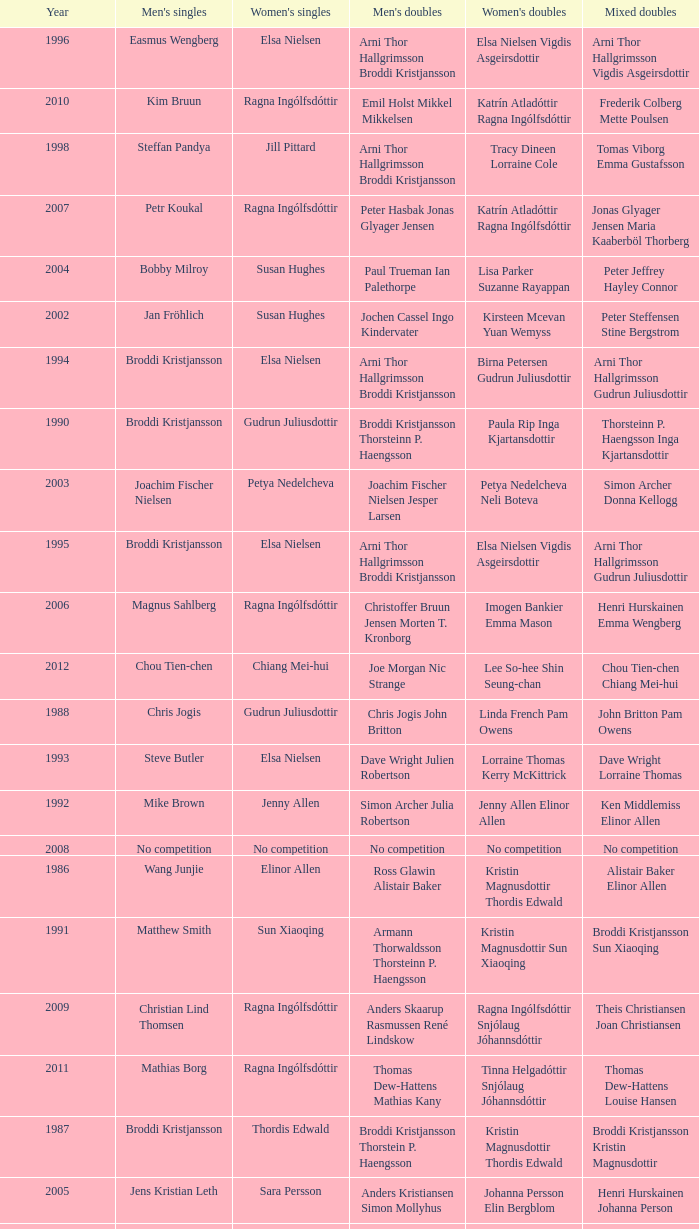In what mixed doubles did Niels Christian Kaldau play in men's singles? Joachim Fisher Jane F. Bramsen. 